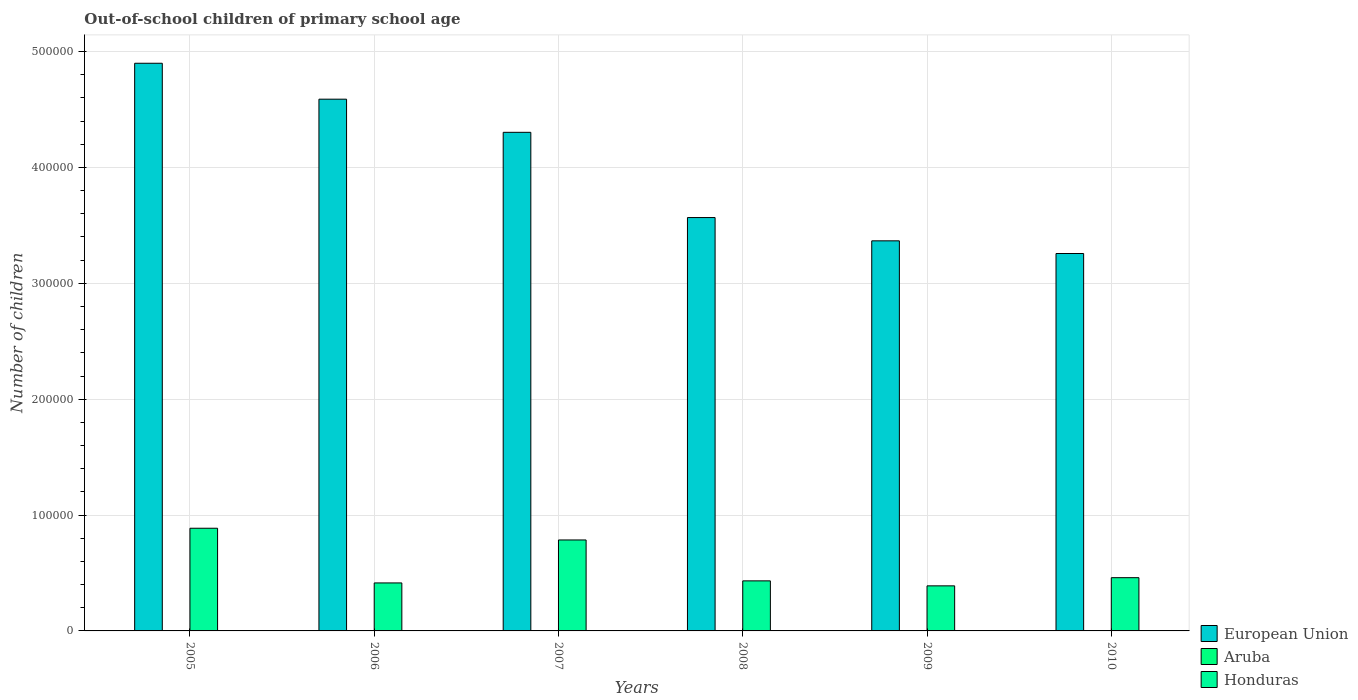Are the number of bars per tick equal to the number of legend labels?
Offer a terse response. Yes. Are the number of bars on each tick of the X-axis equal?
Provide a succinct answer. Yes. How many bars are there on the 5th tick from the left?
Offer a terse response. 3. How many bars are there on the 5th tick from the right?
Your response must be concise. 3. In how many cases, is the number of bars for a given year not equal to the number of legend labels?
Your answer should be very brief. 0. What is the number of out-of-school children in Honduras in 2010?
Give a very brief answer. 4.59e+04. Across all years, what is the maximum number of out-of-school children in Honduras?
Keep it short and to the point. 8.86e+04. Across all years, what is the minimum number of out-of-school children in Honduras?
Provide a succinct answer. 3.89e+04. In which year was the number of out-of-school children in Honduras maximum?
Give a very brief answer. 2005. In which year was the number of out-of-school children in European Union minimum?
Ensure brevity in your answer.  2010. What is the total number of out-of-school children in European Union in the graph?
Provide a short and direct response. 2.40e+06. What is the difference between the number of out-of-school children in European Union in 2007 and that in 2010?
Ensure brevity in your answer.  1.05e+05. What is the difference between the number of out-of-school children in European Union in 2008 and the number of out-of-school children in Aruba in 2010?
Make the answer very short. 3.57e+05. What is the average number of out-of-school children in European Union per year?
Offer a terse response. 4.00e+05. In the year 2010, what is the difference between the number of out-of-school children in Honduras and number of out-of-school children in European Union?
Your answer should be very brief. -2.80e+05. What is the ratio of the number of out-of-school children in Aruba in 2006 to that in 2008?
Provide a short and direct response. 1.58. What is the difference between the highest and the second highest number of out-of-school children in Aruba?
Your response must be concise. 164. What is the difference between the highest and the lowest number of out-of-school children in Aruba?
Provide a short and direct response. 272. What does the 3rd bar from the left in 2006 represents?
Your answer should be very brief. Honduras. What does the 2nd bar from the right in 2006 represents?
Provide a succinct answer. Aruba. Is it the case that in every year, the sum of the number of out-of-school children in Honduras and number of out-of-school children in Aruba is greater than the number of out-of-school children in European Union?
Provide a succinct answer. No. How many bars are there?
Keep it short and to the point. 18. Are all the bars in the graph horizontal?
Your answer should be compact. No. What is the difference between two consecutive major ticks on the Y-axis?
Your answer should be very brief. 1.00e+05. Are the values on the major ticks of Y-axis written in scientific E-notation?
Provide a short and direct response. No. Does the graph contain any zero values?
Provide a succinct answer. No. Does the graph contain grids?
Make the answer very short. Yes. Where does the legend appear in the graph?
Your answer should be compact. Bottom right. How many legend labels are there?
Provide a succinct answer. 3. What is the title of the graph?
Offer a very short reply. Out-of-school children of primary school age. Does "Low & middle income" appear as one of the legend labels in the graph?
Your answer should be compact. No. What is the label or title of the X-axis?
Your answer should be very brief. Years. What is the label or title of the Y-axis?
Your response must be concise. Number of children. What is the Number of children in European Union in 2005?
Ensure brevity in your answer.  4.90e+05. What is the Number of children of Aruba in 2005?
Offer a terse response. 186. What is the Number of children in Honduras in 2005?
Your response must be concise. 8.86e+04. What is the Number of children of European Union in 2006?
Provide a succinct answer. 4.59e+05. What is the Number of children of Aruba in 2006?
Your answer should be very brief. 123. What is the Number of children of Honduras in 2006?
Offer a very short reply. 4.14e+04. What is the Number of children of European Union in 2007?
Your answer should be very brief. 4.30e+05. What is the Number of children of Aruba in 2007?
Your response must be concise. 96. What is the Number of children of Honduras in 2007?
Your answer should be very brief. 7.85e+04. What is the Number of children of European Union in 2008?
Keep it short and to the point. 3.57e+05. What is the Number of children in Aruba in 2008?
Provide a short and direct response. 78. What is the Number of children of Honduras in 2008?
Offer a terse response. 4.32e+04. What is the Number of children of European Union in 2009?
Provide a short and direct response. 3.37e+05. What is the Number of children in Aruba in 2009?
Your response must be concise. 350. What is the Number of children in Honduras in 2009?
Provide a succinct answer. 3.89e+04. What is the Number of children in European Union in 2010?
Offer a very short reply. 3.26e+05. What is the Number of children in Aruba in 2010?
Keep it short and to the point. 93. What is the Number of children in Honduras in 2010?
Your response must be concise. 4.59e+04. Across all years, what is the maximum Number of children in European Union?
Give a very brief answer. 4.90e+05. Across all years, what is the maximum Number of children in Aruba?
Your response must be concise. 350. Across all years, what is the maximum Number of children in Honduras?
Give a very brief answer. 8.86e+04. Across all years, what is the minimum Number of children of European Union?
Ensure brevity in your answer.  3.26e+05. Across all years, what is the minimum Number of children in Honduras?
Provide a short and direct response. 3.89e+04. What is the total Number of children of European Union in the graph?
Provide a succinct answer. 2.40e+06. What is the total Number of children in Aruba in the graph?
Give a very brief answer. 926. What is the total Number of children in Honduras in the graph?
Provide a succinct answer. 3.37e+05. What is the difference between the Number of children in European Union in 2005 and that in 2006?
Offer a very short reply. 3.10e+04. What is the difference between the Number of children of Honduras in 2005 and that in 2006?
Provide a short and direct response. 4.72e+04. What is the difference between the Number of children of European Union in 2005 and that in 2007?
Your answer should be very brief. 5.96e+04. What is the difference between the Number of children in Aruba in 2005 and that in 2007?
Provide a short and direct response. 90. What is the difference between the Number of children of Honduras in 2005 and that in 2007?
Your response must be concise. 1.01e+04. What is the difference between the Number of children of European Union in 2005 and that in 2008?
Your response must be concise. 1.33e+05. What is the difference between the Number of children in Aruba in 2005 and that in 2008?
Provide a succinct answer. 108. What is the difference between the Number of children of Honduras in 2005 and that in 2008?
Keep it short and to the point. 4.54e+04. What is the difference between the Number of children of European Union in 2005 and that in 2009?
Your answer should be compact. 1.53e+05. What is the difference between the Number of children in Aruba in 2005 and that in 2009?
Offer a terse response. -164. What is the difference between the Number of children in Honduras in 2005 and that in 2009?
Your answer should be compact. 4.97e+04. What is the difference between the Number of children in European Union in 2005 and that in 2010?
Offer a very short reply. 1.64e+05. What is the difference between the Number of children of Aruba in 2005 and that in 2010?
Offer a terse response. 93. What is the difference between the Number of children of Honduras in 2005 and that in 2010?
Your answer should be very brief. 4.27e+04. What is the difference between the Number of children in European Union in 2006 and that in 2007?
Provide a short and direct response. 2.86e+04. What is the difference between the Number of children in Aruba in 2006 and that in 2007?
Your answer should be very brief. 27. What is the difference between the Number of children of Honduras in 2006 and that in 2007?
Give a very brief answer. -3.71e+04. What is the difference between the Number of children of European Union in 2006 and that in 2008?
Your answer should be very brief. 1.02e+05. What is the difference between the Number of children of Aruba in 2006 and that in 2008?
Provide a short and direct response. 45. What is the difference between the Number of children in Honduras in 2006 and that in 2008?
Provide a succinct answer. -1774. What is the difference between the Number of children of European Union in 2006 and that in 2009?
Give a very brief answer. 1.22e+05. What is the difference between the Number of children of Aruba in 2006 and that in 2009?
Provide a succinct answer. -227. What is the difference between the Number of children of Honduras in 2006 and that in 2009?
Provide a short and direct response. 2526. What is the difference between the Number of children in European Union in 2006 and that in 2010?
Provide a short and direct response. 1.33e+05. What is the difference between the Number of children of Aruba in 2006 and that in 2010?
Make the answer very short. 30. What is the difference between the Number of children in Honduras in 2006 and that in 2010?
Provide a short and direct response. -4521. What is the difference between the Number of children of European Union in 2007 and that in 2008?
Keep it short and to the point. 7.36e+04. What is the difference between the Number of children of Honduras in 2007 and that in 2008?
Provide a succinct answer. 3.53e+04. What is the difference between the Number of children of European Union in 2007 and that in 2009?
Offer a terse response. 9.36e+04. What is the difference between the Number of children of Aruba in 2007 and that in 2009?
Ensure brevity in your answer.  -254. What is the difference between the Number of children in Honduras in 2007 and that in 2009?
Offer a terse response. 3.96e+04. What is the difference between the Number of children of European Union in 2007 and that in 2010?
Provide a succinct answer. 1.05e+05. What is the difference between the Number of children in Honduras in 2007 and that in 2010?
Ensure brevity in your answer.  3.26e+04. What is the difference between the Number of children in European Union in 2008 and that in 2009?
Ensure brevity in your answer.  2.01e+04. What is the difference between the Number of children in Aruba in 2008 and that in 2009?
Make the answer very short. -272. What is the difference between the Number of children of Honduras in 2008 and that in 2009?
Give a very brief answer. 4300. What is the difference between the Number of children in European Union in 2008 and that in 2010?
Offer a very short reply. 3.10e+04. What is the difference between the Number of children in Aruba in 2008 and that in 2010?
Ensure brevity in your answer.  -15. What is the difference between the Number of children in Honduras in 2008 and that in 2010?
Ensure brevity in your answer.  -2747. What is the difference between the Number of children of European Union in 2009 and that in 2010?
Provide a succinct answer. 1.09e+04. What is the difference between the Number of children of Aruba in 2009 and that in 2010?
Keep it short and to the point. 257. What is the difference between the Number of children of Honduras in 2009 and that in 2010?
Your answer should be compact. -7047. What is the difference between the Number of children in European Union in 2005 and the Number of children in Aruba in 2006?
Provide a short and direct response. 4.90e+05. What is the difference between the Number of children of European Union in 2005 and the Number of children of Honduras in 2006?
Your response must be concise. 4.48e+05. What is the difference between the Number of children in Aruba in 2005 and the Number of children in Honduras in 2006?
Offer a very short reply. -4.12e+04. What is the difference between the Number of children in European Union in 2005 and the Number of children in Aruba in 2007?
Offer a terse response. 4.90e+05. What is the difference between the Number of children of European Union in 2005 and the Number of children of Honduras in 2007?
Provide a succinct answer. 4.11e+05. What is the difference between the Number of children in Aruba in 2005 and the Number of children in Honduras in 2007?
Your response must be concise. -7.83e+04. What is the difference between the Number of children in European Union in 2005 and the Number of children in Aruba in 2008?
Ensure brevity in your answer.  4.90e+05. What is the difference between the Number of children of European Union in 2005 and the Number of children of Honduras in 2008?
Ensure brevity in your answer.  4.47e+05. What is the difference between the Number of children of Aruba in 2005 and the Number of children of Honduras in 2008?
Your answer should be compact. -4.30e+04. What is the difference between the Number of children of European Union in 2005 and the Number of children of Aruba in 2009?
Give a very brief answer. 4.90e+05. What is the difference between the Number of children of European Union in 2005 and the Number of children of Honduras in 2009?
Offer a very short reply. 4.51e+05. What is the difference between the Number of children of Aruba in 2005 and the Number of children of Honduras in 2009?
Offer a very short reply. -3.87e+04. What is the difference between the Number of children in European Union in 2005 and the Number of children in Aruba in 2010?
Offer a terse response. 4.90e+05. What is the difference between the Number of children of European Union in 2005 and the Number of children of Honduras in 2010?
Provide a short and direct response. 4.44e+05. What is the difference between the Number of children of Aruba in 2005 and the Number of children of Honduras in 2010?
Offer a very short reply. -4.58e+04. What is the difference between the Number of children of European Union in 2006 and the Number of children of Aruba in 2007?
Offer a terse response. 4.59e+05. What is the difference between the Number of children in European Union in 2006 and the Number of children in Honduras in 2007?
Make the answer very short. 3.80e+05. What is the difference between the Number of children in Aruba in 2006 and the Number of children in Honduras in 2007?
Give a very brief answer. -7.84e+04. What is the difference between the Number of children in European Union in 2006 and the Number of children in Aruba in 2008?
Your response must be concise. 4.59e+05. What is the difference between the Number of children in European Union in 2006 and the Number of children in Honduras in 2008?
Provide a succinct answer. 4.16e+05. What is the difference between the Number of children in Aruba in 2006 and the Number of children in Honduras in 2008?
Keep it short and to the point. -4.31e+04. What is the difference between the Number of children of European Union in 2006 and the Number of children of Aruba in 2009?
Give a very brief answer. 4.59e+05. What is the difference between the Number of children in European Union in 2006 and the Number of children in Honduras in 2009?
Give a very brief answer. 4.20e+05. What is the difference between the Number of children of Aruba in 2006 and the Number of children of Honduras in 2009?
Your response must be concise. -3.88e+04. What is the difference between the Number of children of European Union in 2006 and the Number of children of Aruba in 2010?
Ensure brevity in your answer.  4.59e+05. What is the difference between the Number of children in European Union in 2006 and the Number of children in Honduras in 2010?
Your answer should be very brief. 4.13e+05. What is the difference between the Number of children of Aruba in 2006 and the Number of children of Honduras in 2010?
Provide a short and direct response. -4.58e+04. What is the difference between the Number of children in European Union in 2007 and the Number of children in Aruba in 2008?
Make the answer very short. 4.30e+05. What is the difference between the Number of children in European Union in 2007 and the Number of children in Honduras in 2008?
Make the answer very short. 3.87e+05. What is the difference between the Number of children in Aruba in 2007 and the Number of children in Honduras in 2008?
Your response must be concise. -4.31e+04. What is the difference between the Number of children of European Union in 2007 and the Number of children of Aruba in 2009?
Your answer should be compact. 4.30e+05. What is the difference between the Number of children of European Union in 2007 and the Number of children of Honduras in 2009?
Provide a short and direct response. 3.91e+05. What is the difference between the Number of children in Aruba in 2007 and the Number of children in Honduras in 2009?
Offer a very short reply. -3.88e+04. What is the difference between the Number of children of European Union in 2007 and the Number of children of Aruba in 2010?
Provide a short and direct response. 4.30e+05. What is the difference between the Number of children of European Union in 2007 and the Number of children of Honduras in 2010?
Ensure brevity in your answer.  3.84e+05. What is the difference between the Number of children in Aruba in 2007 and the Number of children in Honduras in 2010?
Ensure brevity in your answer.  -4.58e+04. What is the difference between the Number of children in European Union in 2008 and the Number of children in Aruba in 2009?
Offer a very short reply. 3.56e+05. What is the difference between the Number of children in European Union in 2008 and the Number of children in Honduras in 2009?
Keep it short and to the point. 3.18e+05. What is the difference between the Number of children in Aruba in 2008 and the Number of children in Honduras in 2009?
Offer a terse response. -3.88e+04. What is the difference between the Number of children in European Union in 2008 and the Number of children in Aruba in 2010?
Your answer should be compact. 3.57e+05. What is the difference between the Number of children of European Union in 2008 and the Number of children of Honduras in 2010?
Provide a succinct answer. 3.11e+05. What is the difference between the Number of children in Aruba in 2008 and the Number of children in Honduras in 2010?
Give a very brief answer. -4.59e+04. What is the difference between the Number of children in European Union in 2009 and the Number of children in Aruba in 2010?
Offer a terse response. 3.37e+05. What is the difference between the Number of children of European Union in 2009 and the Number of children of Honduras in 2010?
Your answer should be very brief. 2.91e+05. What is the difference between the Number of children in Aruba in 2009 and the Number of children in Honduras in 2010?
Provide a short and direct response. -4.56e+04. What is the average Number of children of European Union per year?
Your answer should be very brief. 4.00e+05. What is the average Number of children in Aruba per year?
Provide a short and direct response. 154.33. What is the average Number of children of Honduras per year?
Your answer should be very brief. 5.61e+04. In the year 2005, what is the difference between the Number of children in European Union and Number of children in Aruba?
Provide a short and direct response. 4.90e+05. In the year 2005, what is the difference between the Number of children in European Union and Number of children in Honduras?
Provide a succinct answer. 4.01e+05. In the year 2005, what is the difference between the Number of children in Aruba and Number of children in Honduras?
Make the answer very short. -8.84e+04. In the year 2006, what is the difference between the Number of children in European Union and Number of children in Aruba?
Make the answer very short. 4.59e+05. In the year 2006, what is the difference between the Number of children of European Union and Number of children of Honduras?
Your answer should be very brief. 4.17e+05. In the year 2006, what is the difference between the Number of children in Aruba and Number of children in Honduras?
Keep it short and to the point. -4.13e+04. In the year 2007, what is the difference between the Number of children of European Union and Number of children of Aruba?
Your answer should be compact. 4.30e+05. In the year 2007, what is the difference between the Number of children in European Union and Number of children in Honduras?
Provide a short and direct response. 3.52e+05. In the year 2007, what is the difference between the Number of children of Aruba and Number of children of Honduras?
Your answer should be very brief. -7.84e+04. In the year 2008, what is the difference between the Number of children in European Union and Number of children in Aruba?
Offer a terse response. 3.57e+05. In the year 2008, what is the difference between the Number of children in European Union and Number of children in Honduras?
Make the answer very short. 3.14e+05. In the year 2008, what is the difference between the Number of children in Aruba and Number of children in Honduras?
Make the answer very short. -4.31e+04. In the year 2009, what is the difference between the Number of children of European Union and Number of children of Aruba?
Offer a terse response. 3.36e+05. In the year 2009, what is the difference between the Number of children of European Union and Number of children of Honduras?
Offer a very short reply. 2.98e+05. In the year 2009, what is the difference between the Number of children of Aruba and Number of children of Honduras?
Your answer should be compact. -3.85e+04. In the year 2010, what is the difference between the Number of children of European Union and Number of children of Aruba?
Offer a very short reply. 3.26e+05. In the year 2010, what is the difference between the Number of children in European Union and Number of children in Honduras?
Keep it short and to the point. 2.80e+05. In the year 2010, what is the difference between the Number of children in Aruba and Number of children in Honduras?
Give a very brief answer. -4.59e+04. What is the ratio of the Number of children of European Union in 2005 to that in 2006?
Make the answer very short. 1.07. What is the ratio of the Number of children in Aruba in 2005 to that in 2006?
Offer a terse response. 1.51. What is the ratio of the Number of children of Honduras in 2005 to that in 2006?
Your answer should be very brief. 2.14. What is the ratio of the Number of children in European Union in 2005 to that in 2007?
Provide a short and direct response. 1.14. What is the ratio of the Number of children of Aruba in 2005 to that in 2007?
Your response must be concise. 1.94. What is the ratio of the Number of children in Honduras in 2005 to that in 2007?
Offer a very short reply. 1.13. What is the ratio of the Number of children in European Union in 2005 to that in 2008?
Ensure brevity in your answer.  1.37. What is the ratio of the Number of children in Aruba in 2005 to that in 2008?
Keep it short and to the point. 2.38. What is the ratio of the Number of children of Honduras in 2005 to that in 2008?
Offer a very short reply. 2.05. What is the ratio of the Number of children of European Union in 2005 to that in 2009?
Give a very brief answer. 1.46. What is the ratio of the Number of children in Aruba in 2005 to that in 2009?
Keep it short and to the point. 0.53. What is the ratio of the Number of children in Honduras in 2005 to that in 2009?
Make the answer very short. 2.28. What is the ratio of the Number of children of European Union in 2005 to that in 2010?
Offer a terse response. 1.5. What is the ratio of the Number of children in Aruba in 2005 to that in 2010?
Provide a short and direct response. 2. What is the ratio of the Number of children of Honduras in 2005 to that in 2010?
Provide a short and direct response. 1.93. What is the ratio of the Number of children in European Union in 2006 to that in 2007?
Offer a very short reply. 1.07. What is the ratio of the Number of children in Aruba in 2006 to that in 2007?
Offer a terse response. 1.28. What is the ratio of the Number of children in Honduras in 2006 to that in 2007?
Ensure brevity in your answer.  0.53. What is the ratio of the Number of children in European Union in 2006 to that in 2008?
Provide a succinct answer. 1.29. What is the ratio of the Number of children of Aruba in 2006 to that in 2008?
Provide a short and direct response. 1.58. What is the ratio of the Number of children in Honduras in 2006 to that in 2008?
Provide a succinct answer. 0.96. What is the ratio of the Number of children of European Union in 2006 to that in 2009?
Give a very brief answer. 1.36. What is the ratio of the Number of children in Aruba in 2006 to that in 2009?
Ensure brevity in your answer.  0.35. What is the ratio of the Number of children in Honduras in 2006 to that in 2009?
Provide a succinct answer. 1.06. What is the ratio of the Number of children of European Union in 2006 to that in 2010?
Offer a very short reply. 1.41. What is the ratio of the Number of children in Aruba in 2006 to that in 2010?
Offer a terse response. 1.32. What is the ratio of the Number of children of Honduras in 2006 to that in 2010?
Your response must be concise. 0.9. What is the ratio of the Number of children in European Union in 2007 to that in 2008?
Give a very brief answer. 1.21. What is the ratio of the Number of children in Aruba in 2007 to that in 2008?
Your answer should be very brief. 1.23. What is the ratio of the Number of children of Honduras in 2007 to that in 2008?
Offer a terse response. 1.82. What is the ratio of the Number of children in European Union in 2007 to that in 2009?
Give a very brief answer. 1.28. What is the ratio of the Number of children of Aruba in 2007 to that in 2009?
Provide a short and direct response. 0.27. What is the ratio of the Number of children in Honduras in 2007 to that in 2009?
Your answer should be compact. 2.02. What is the ratio of the Number of children of European Union in 2007 to that in 2010?
Give a very brief answer. 1.32. What is the ratio of the Number of children in Aruba in 2007 to that in 2010?
Ensure brevity in your answer.  1.03. What is the ratio of the Number of children of Honduras in 2007 to that in 2010?
Offer a terse response. 1.71. What is the ratio of the Number of children in European Union in 2008 to that in 2009?
Offer a terse response. 1.06. What is the ratio of the Number of children in Aruba in 2008 to that in 2009?
Provide a succinct answer. 0.22. What is the ratio of the Number of children in Honduras in 2008 to that in 2009?
Offer a terse response. 1.11. What is the ratio of the Number of children of European Union in 2008 to that in 2010?
Offer a terse response. 1.1. What is the ratio of the Number of children of Aruba in 2008 to that in 2010?
Provide a succinct answer. 0.84. What is the ratio of the Number of children in Honduras in 2008 to that in 2010?
Provide a succinct answer. 0.94. What is the ratio of the Number of children in European Union in 2009 to that in 2010?
Your response must be concise. 1.03. What is the ratio of the Number of children in Aruba in 2009 to that in 2010?
Ensure brevity in your answer.  3.76. What is the ratio of the Number of children in Honduras in 2009 to that in 2010?
Offer a terse response. 0.85. What is the difference between the highest and the second highest Number of children of European Union?
Ensure brevity in your answer.  3.10e+04. What is the difference between the highest and the second highest Number of children in Aruba?
Offer a very short reply. 164. What is the difference between the highest and the second highest Number of children in Honduras?
Your answer should be compact. 1.01e+04. What is the difference between the highest and the lowest Number of children in European Union?
Ensure brevity in your answer.  1.64e+05. What is the difference between the highest and the lowest Number of children in Aruba?
Offer a terse response. 272. What is the difference between the highest and the lowest Number of children of Honduras?
Offer a terse response. 4.97e+04. 